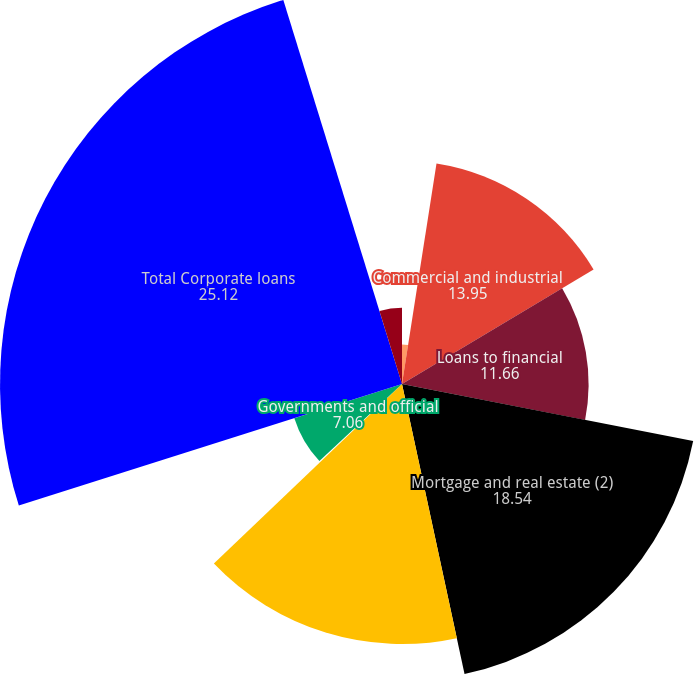Convert chart. <chart><loc_0><loc_0><loc_500><loc_500><pie_chart><fcel>In millions of dollars at year<fcel>Commercial and industrial<fcel>Loans to financial<fcel>Mortgage and real estate (2)<fcel>Installment revolving credit<fcel>Lease financing<fcel>Governments and official<fcel>Total Corporate loans<fcel>Net unearned income<nl><fcel>2.47%<fcel>13.95%<fcel>11.66%<fcel>18.54%<fcel>16.25%<fcel>0.18%<fcel>7.06%<fcel>25.12%<fcel>4.77%<nl></chart> 